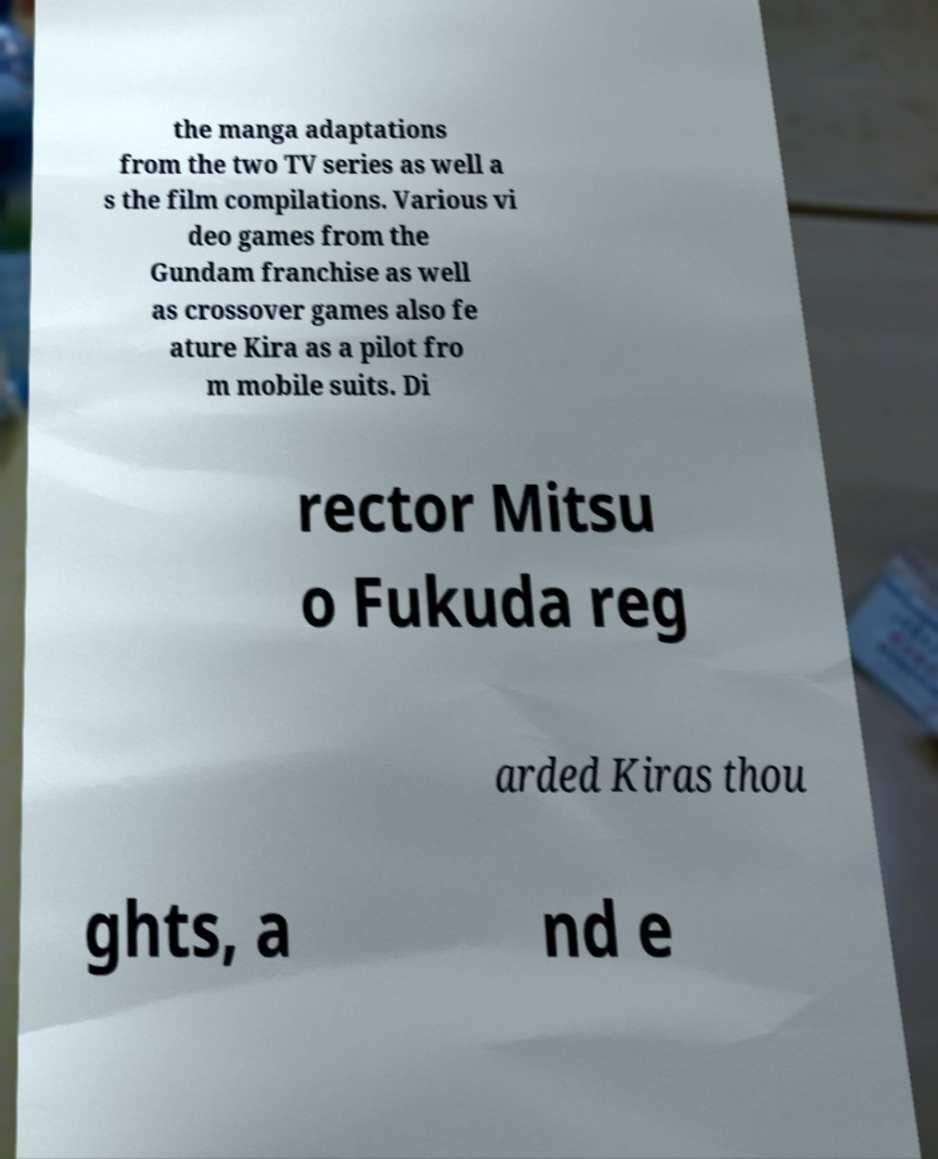Can you accurately transcribe the text from the provided image for me? the manga adaptations from the two TV series as well a s the film compilations. Various vi deo games from the Gundam franchise as well as crossover games also fe ature Kira as a pilot fro m mobile suits. Di rector Mitsu o Fukuda reg arded Kiras thou ghts, a nd e 